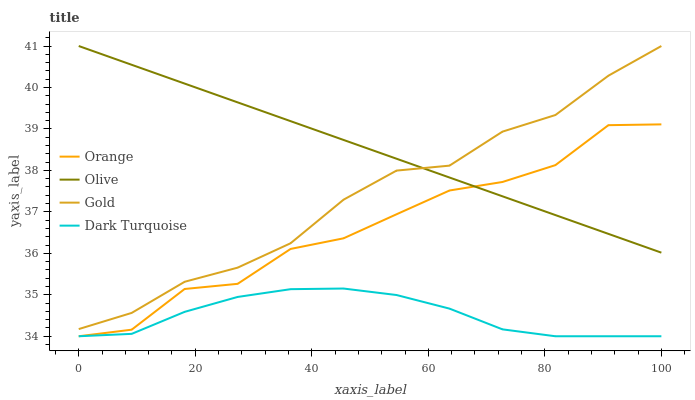Does Dark Turquoise have the minimum area under the curve?
Answer yes or no. Yes. Does Olive have the maximum area under the curve?
Answer yes or no. Yes. Does Gold have the minimum area under the curve?
Answer yes or no. No. Does Gold have the maximum area under the curve?
Answer yes or no. No. Is Olive the smoothest?
Answer yes or no. Yes. Is Orange the roughest?
Answer yes or no. Yes. Is Gold the smoothest?
Answer yes or no. No. Is Gold the roughest?
Answer yes or no. No. Does Orange have the lowest value?
Answer yes or no. Yes. Does Gold have the lowest value?
Answer yes or no. No. Does Gold have the highest value?
Answer yes or no. Yes. Does Dark Turquoise have the highest value?
Answer yes or no. No. Is Dark Turquoise less than Olive?
Answer yes or no. Yes. Is Gold greater than Dark Turquoise?
Answer yes or no. Yes. Does Olive intersect Orange?
Answer yes or no. Yes. Is Olive less than Orange?
Answer yes or no. No. Is Olive greater than Orange?
Answer yes or no. No. Does Dark Turquoise intersect Olive?
Answer yes or no. No. 